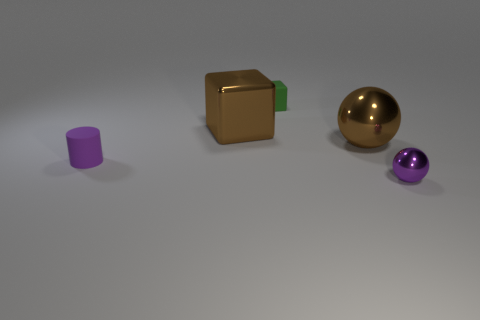There is a purple thing right of the tiny purple matte thing; is it the same size as the metal ball behind the small metal object?
Give a very brief answer. No. How many other things are the same size as the brown metallic ball?
Offer a terse response. 1. Is the size of the purple rubber object the same as the ball that is behind the purple rubber thing?
Your answer should be very brief. No. Does the green object have the same size as the purple metallic ball?
Provide a succinct answer. Yes. There is a metal thing that is in front of the brown block and behind the small purple sphere; what shape is it?
Give a very brief answer. Sphere. What number of purple spheres have the same material as the green object?
Your answer should be very brief. 0. How many small green blocks are behind the metal sphere right of the brown ball?
Make the answer very short. 1. What is the shape of the green object that is right of the purple thing that is behind the thing that is to the right of the large brown shiny ball?
Provide a short and direct response. Cube. What is the size of the sphere that is the same color as the cylinder?
Ensure brevity in your answer.  Small. What number of objects are either rubber cylinders or green objects?
Offer a terse response. 2. 